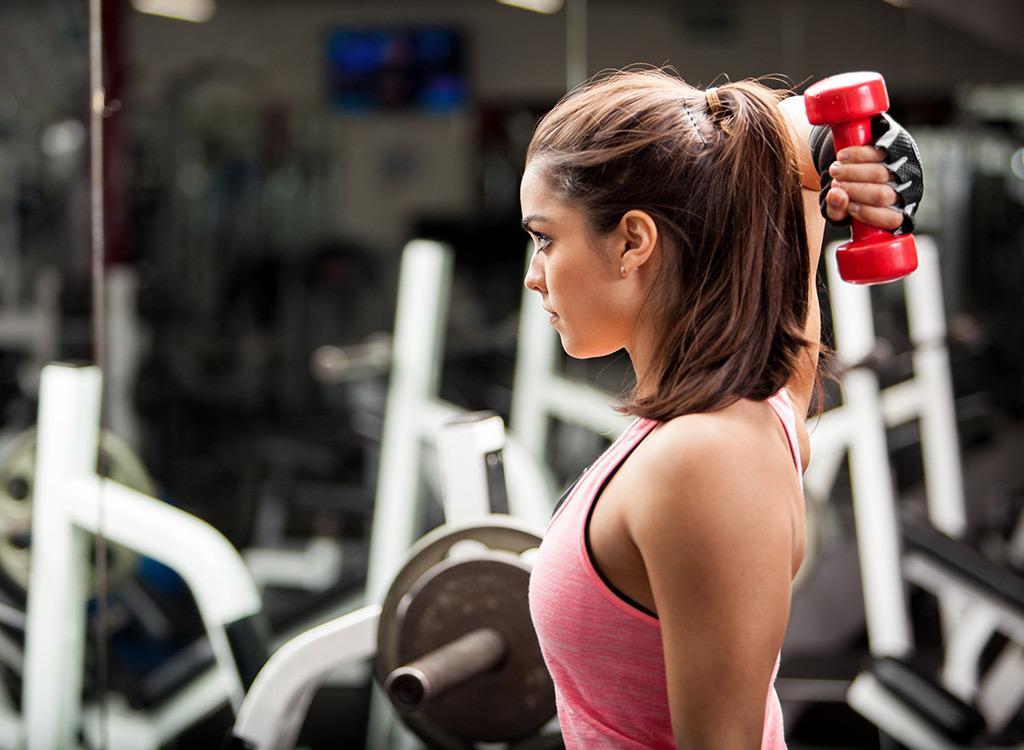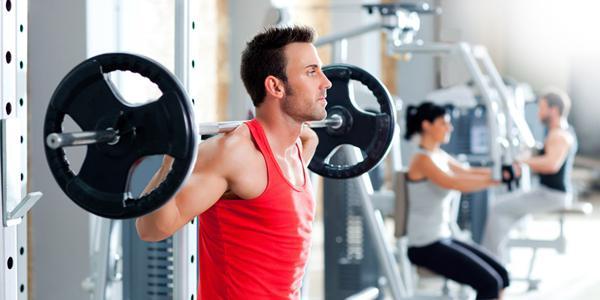The first image is the image on the left, the second image is the image on the right. Evaluate the accuracy of this statement regarding the images: "The left and right image contains  a total of four people working out.". Is it true? Answer yes or no. Yes. The first image is the image on the left, the second image is the image on the right. Considering the images on both sides, is "At least one of the images has a man." valid? Answer yes or no. Yes. 